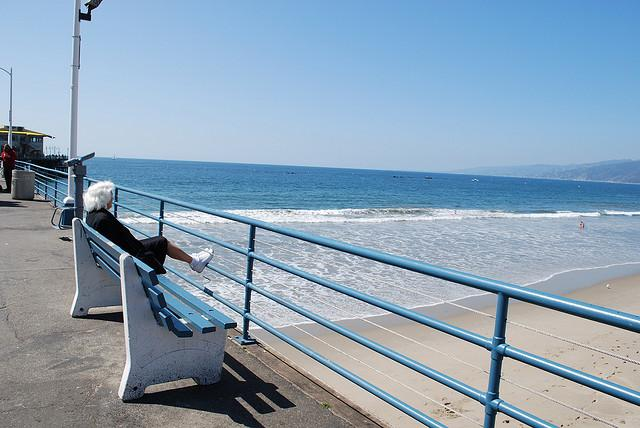What is the name of the structure the bench is sitting on? boardwalk 